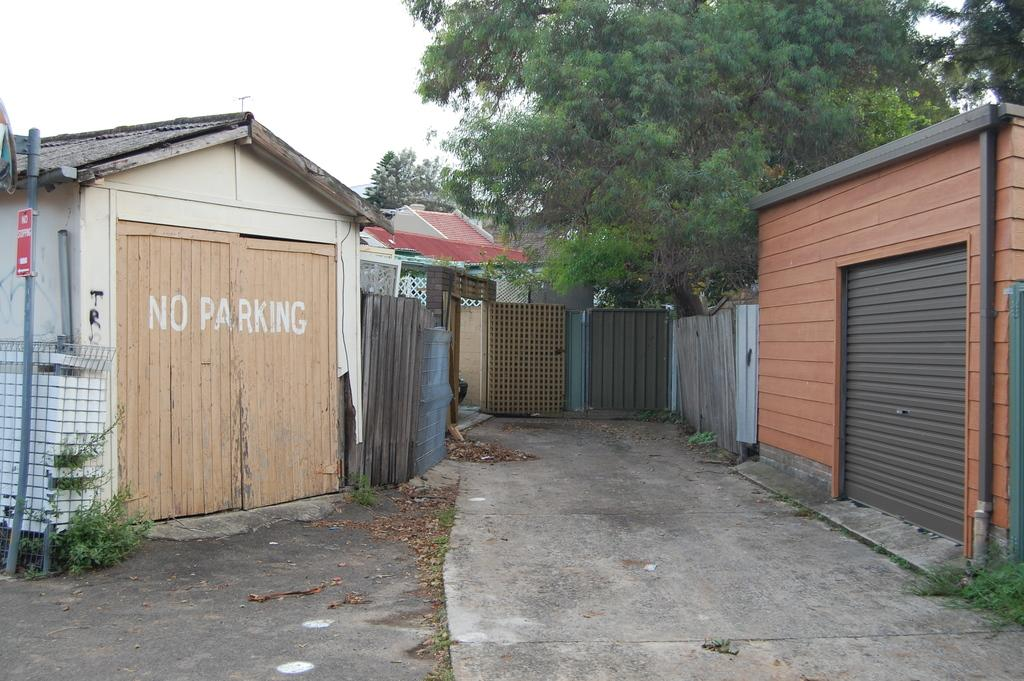What is the main feature in the middle of the image? There is a road in the middle of the image. What is located in front of the road? There is a gate in front of the road. What can be seen on either side of the road? There are buildings on either side of the road. What is located behind the gate? There is a tree and a building behind the gate. What is visible above the gate? The sky is visible above the gate. What type of knife is being used to cut the tree behind the gate? There is no knife present in the image, and the tree is not being cut. 